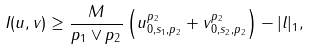<formula> <loc_0><loc_0><loc_500><loc_500>I ( u , v ) & \geq \frac { M } { p _ { 1 } \vee p _ { 2 } } \left ( \| u \| _ { 0 , s _ { 1 } , p _ { 2 } } ^ { p _ { 2 } } + \| v \| _ { 0 , s _ { 2 } , p _ { 2 } } ^ { p _ { 2 } } \right ) - | l | _ { 1 } , \\</formula> 